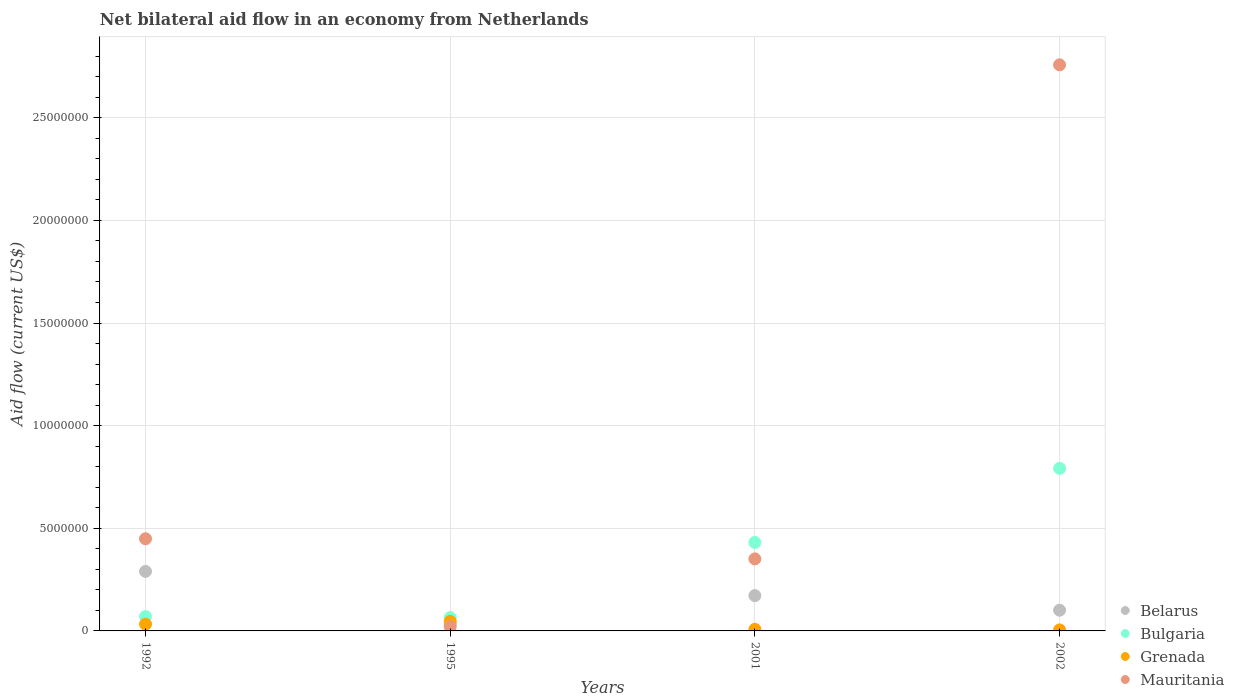Is the number of dotlines equal to the number of legend labels?
Your answer should be very brief. Yes. What is the net bilateral aid flow in Mauritania in 2001?
Your answer should be compact. 3.51e+06. Across all years, what is the maximum net bilateral aid flow in Mauritania?
Ensure brevity in your answer.  2.76e+07. In which year was the net bilateral aid flow in Mauritania maximum?
Provide a succinct answer. 2002. In which year was the net bilateral aid flow in Grenada minimum?
Offer a terse response. 2002. What is the total net bilateral aid flow in Mauritania in the graph?
Offer a very short reply. 3.58e+07. What is the difference between the net bilateral aid flow in Belarus in 1992 and that in 2002?
Your answer should be compact. 1.89e+06. What is the difference between the net bilateral aid flow in Grenada in 2002 and the net bilateral aid flow in Bulgaria in 1992?
Your answer should be compact. -6.50e+05. What is the average net bilateral aid flow in Mauritania per year?
Ensure brevity in your answer.  8.95e+06. In the year 2001, what is the difference between the net bilateral aid flow in Belarus and net bilateral aid flow in Bulgaria?
Your answer should be very brief. -2.59e+06. What is the ratio of the net bilateral aid flow in Bulgaria in 1992 to that in 2002?
Make the answer very short. 0.09. Is the net bilateral aid flow in Belarus in 1992 less than that in 1995?
Provide a short and direct response. No. Is the difference between the net bilateral aid flow in Belarus in 2001 and 2002 greater than the difference between the net bilateral aid flow in Bulgaria in 2001 and 2002?
Your response must be concise. Yes. What is the difference between the highest and the second highest net bilateral aid flow in Bulgaria?
Give a very brief answer. 3.61e+06. In how many years, is the net bilateral aid flow in Grenada greater than the average net bilateral aid flow in Grenada taken over all years?
Your answer should be compact. 2. Is it the case that in every year, the sum of the net bilateral aid flow in Bulgaria and net bilateral aid flow in Grenada  is greater than the sum of net bilateral aid flow in Belarus and net bilateral aid flow in Mauritania?
Your response must be concise. No. Is the net bilateral aid flow in Mauritania strictly less than the net bilateral aid flow in Bulgaria over the years?
Give a very brief answer. No. How many years are there in the graph?
Offer a terse response. 4. Are the values on the major ticks of Y-axis written in scientific E-notation?
Your answer should be very brief. No. Does the graph contain any zero values?
Offer a terse response. No. Does the graph contain grids?
Give a very brief answer. Yes. How many legend labels are there?
Your response must be concise. 4. How are the legend labels stacked?
Provide a succinct answer. Vertical. What is the title of the graph?
Provide a succinct answer. Net bilateral aid flow in an economy from Netherlands. Does "Cambodia" appear as one of the legend labels in the graph?
Your answer should be very brief. No. What is the label or title of the Y-axis?
Offer a very short reply. Aid flow (current US$). What is the Aid flow (current US$) in Belarus in 1992?
Ensure brevity in your answer.  2.90e+06. What is the Aid flow (current US$) in Grenada in 1992?
Your answer should be compact. 3.30e+05. What is the Aid flow (current US$) in Mauritania in 1992?
Provide a short and direct response. 4.49e+06. What is the Aid flow (current US$) in Belarus in 1995?
Make the answer very short. 3.40e+05. What is the Aid flow (current US$) of Bulgaria in 1995?
Ensure brevity in your answer.  6.50e+05. What is the Aid flow (current US$) of Grenada in 1995?
Provide a succinct answer. 4.70e+05. What is the Aid flow (current US$) of Mauritania in 1995?
Provide a short and direct response. 2.10e+05. What is the Aid flow (current US$) of Belarus in 2001?
Provide a succinct answer. 1.72e+06. What is the Aid flow (current US$) of Bulgaria in 2001?
Provide a succinct answer. 4.31e+06. What is the Aid flow (current US$) of Grenada in 2001?
Provide a succinct answer. 8.00e+04. What is the Aid flow (current US$) of Mauritania in 2001?
Make the answer very short. 3.51e+06. What is the Aid flow (current US$) in Belarus in 2002?
Your answer should be compact. 1.01e+06. What is the Aid flow (current US$) in Bulgaria in 2002?
Make the answer very short. 7.92e+06. What is the Aid flow (current US$) of Mauritania in 2002?
Offer a terse response. 2.76e+07. Across all years, what is the maximum Aid flow (current US$) in Belarus?
Provide a short and direct response. 2.90e+06. Across all years, what is the maximum Aid flow (current US$) in Bulgaria?
Offer a very short reply. 7.92e+06. Across all years, what is the maximum Aid flow (current US$) of Grenada?
Your answer should be compact. 4.70e+05. Across all years, what is the maximum Aid flow (current US$) in Mauritania?
Your answer should be very brief. 2.76e+07. Across all years, what is the minimum Aid flow (current US$) in Belarus?
Provide a succinct answer. 3.40e+05. Across all years, what is the minimum Aid flow (current US$) of Bulgaria?
Make the answer very short. 6.50e+05. Across all years, what is the minimum Aid flow (current US$) in Grenada?
Provide a short and direct response. 5.00e+04. Across all years, what is the minimum Aid flow (current US$) in Mauritania?
Give a very brief answer. 2.10e+05. What is the total Aid flow (current US$) of Belarus in the graph?
Make the answer very short. 5.97e+06. What is the total Aid flow (current US$) in Bulgaria in the graph?
Give a very brief answer. 1.36e+07. What is the total Aid flow (current US$) in Grenada in the graph?
Your answer should be very brief. 9.30e+05. What is the total Aid flow (current US$) in Mauritania in the graph?
Make the answer very short. 3.58e+07. What is the difference between the Aid flow (current US$) in Belarus in 1992 and that in 1995?
Your answer should be compact. 2.56e+06. What is the difference between the Aid flow (current US$) of Mauritania in 1992 and that in 1995?
Offer a very short reply. 4.28e+06. What is the difference between the Aid flow (current US$) of Belarus in 1992 and that in 2001?
Provide a short and direct response. 1.18e+06. What is the difference between the Aid flow (current US$) in Bulgaria in 1992 and that in 2001?
Ensure brevity in your answer.  -3.61e+06. What is the difference between the Aid flow (current US$) in Grenada in 1992 and that in 2001?
Provide a succinct answer. 2.50e+05. What is the difference between the Aid flow (current US$) of Mauritania in 1992 and that in 2001?
Provide a short and direct response. 9.80e+05. What is the difference between the Aid flow (current US$) of Belarus in 1992 and that in 2002?
Your response must be concise. 1.89e+06. What is the difference between the Aid flow (current US$) in Bulgaria in 1992 and that in 2002?
Make the answer very short. -7.22e+06. What is the difference between the Aid flow (current US$) of Mauritania in 1992 and that in 2002?
Provide a succinct answer. -2.31e+07. What is the difference between the Aid flow (current US$) in Belarus in 1995 and that in 2001?
Give a very brief answer. -1.38e+06. What is the difference between the Aid flow (current US$) in Bulgaria in 1995 and that in 2001?
Keep it short and to the point. -3.66e+06. What is the difference between the Aid flow (current US$) of Mauritania in 1995 and that in 2001?
Your answer should be compact. -3.30e+06. What is the difference between the Aid flow (current US$) of Belarus in 1995 and that in 2002?
Offer a very short reply. -6.70e+05. What is the difference between the Aid flow (current US$) in Bulgaria in 1995 and that in 2002?
Ensure brevity in your answer.  -7.27e+06. What is the difference between the Aid flow (current US$) in Grenada in 1995 and that in 2002?
Your response must be concise. 4.20e+05. What is the difference between the Aid flow (current US$) of Mauritania in 1995 and that in 2002?
Offer a terse response. -2.74e+07. What is the difference between the Aid flow (current US$) in Belarus in 2001 and that in 2002?
Make the answer very short. 7.10e+05. What is the difference between the Aid flow (current US$) of Bulgaria in 2001 and that in 2002?
Give a very brief answer. -3.61e+06. What is the difference between the Aid flow (current US$) in Mauritania in 2001 and that in 2002?
Your response must be concise. -2.41e+07. What is the difference between the Aid flow (current US$) of Belarus in 1992 and the Aid flow (current US$) of Bulgaria in 1995?
Offer a terse response. 2.25e+06. What is the difference between the Aid flow (current US$) of Belarus in 1992 and the Aid flow (current US$) of Grenada in 1995?
Make the answer very short. 2.43e+06. What is the difference between the Aid flow (current US$) of Belarus in 1992 and the Aid flow (current US$) of Mauritania in 1995?
Make the answer very short. 2.69e+06. What is the difference between the Aid flow (current US$) of Bulgaria in 1992 and the Aid flow (current US$) of Grenada in 1995?
Make the answer very short. 2.30e+05. What is the difference between the Aid flow (current US$) of Grenada in 1992 and the Aid flow (current US$) of Mauritania in 1995?
Keep it short and to the point. 1.20e+05. What is the difference between the Aid flow (current US$) of Belarus in 1992 and the Aid flow (current US$) of Bulgaria in 2001?
Keep it short and to the point. -1.41e+06. What is the difference between the Aid flow (current US$) in Belarus in 1992 and the Aid flow (current US$) in Grenada in 2001?
Your answer should be compact. 2.82e+06. What is the difference between the Aid flow (current US$) of Belarus in 1992 and the Aid flow (current US$) of Mauritania in 2001?
Your response must be concise. -6.10e+05. What is the difference between the Aid flow (current US$) in Bulgaria in 1992 and the Aid flow (current US$) in Grenada in 2001?
Keep it short and to the point. 6.20e+05. What is the difference between the Aid flow (current US$) in Bulgaria in 1992 and the Aid flow (current US$) in Mauritania in 2001?
Keep it short and to the point. -2.81e+06. What is the difference between the Aid flow (current US$) in Grenada in 1992 and the Aid flow (current US$) in Mauritania in 2001?
Provide a succinct answer. -3.18e+06. What is the difference between the Aid flow (current US$) in Belarus in 1992 and the Aid flow (current US$) in Bulgaria in 2002?
Make the answer very short. -5.02e+06. What is the difference between the Aid flow (current US$) of Belarus in 1992 and the Aid flow (current US$) of Grenada in 2002?
Provide a succinct answer. 2.85e+06. What is the difference between the Aid flow (current US$) in Belarus in 1992 and the Aid flow (current US$) in Mauritania in 2002?
Provide a short and direct response. -2.47e+07. What is the difference between the Aid flow (current US$) of Bulgaria in 1992 and the Aid flow (current US$) of Grenada in 2002?
Keep it short and to the point. 6.50e+05. What is the difference between the Aid flow (current US$) in Bulgaria in 1992 and the Aid flow (current US$) in Mauritania in 2002?
Offer a terse response. -2.69e+07. What is the difference between the Aid flow (current US$) of Grenada in 1992 and the Aid flow (current US$) of Mauritania in 2002?
Keep it short and to the point. -2.72e+07. What is the difference between the Aid flow (current US$) in Belarus in 1995 and the Aid flow (current US$) in Bulgaria in 2001?
Offer a very short reply. -3.97e+06. What is the difference between the Aid flow (current US$) of Belarus in 1995 and the Aid flow (current US$) of Grenada in 2001?
Keep it short and to the point. 2.60e+05. What is the difference between the Aid flow (current US$) of Belarus in 1995 and the Aid flow (current US$) of Mauritania in 2001?
Your answer should be compact. -3.17e+06. What is the difference between the Aid flow (current US$) of Bulgaria in 1995 and the Aid flow (current US$) of Grenada in 2001?
Give a very brief answer. 5.70e+05. What is the difference between the Aid flow (current US$) in Bulgaria in 1995 and the Aid flow (current US$) in Mauritania in 2001?
Your response must be concise. -2.86e+06. What is the difference between the Aid flow (current US$) in Grenada in 1995 and the Aid flow (current US$) in Mauritania in 2001?
Ensure brevity in your answer.  -3.04e+06. What is the difference between the Aid flow (current US$) of Belarus in 1995 and the Aid flow (current US$) of Bulgaria in 2002?
Offer a very short reply. -7.58e+06. What is the difference between the Aid flow (current US$) in Belarus in 1995 and the Aid flow (current US$) in Grenada in 2002?
Keep it short and to the point. 2.90e+05. What is the difference between the Aid flow (current US$) of Belarus in 1995 and the Aid flow (current US$) of Mauritania in 2002?
Provide a succinct answer. -2.72e+07. What is the difference between the Aid flow (current US$) of Bulgaria in 1995 and the Aid flow (current US$) of Mauritania in 2002?
Your response must be concise. -2.69e+07. What is the difference between the Aid flow (current US$) in Grenada in 1995 and the Aid flow (current US$) in Mauritania in 2002?
Your response must be concise. -2.71e+07. What is the difference between the Aid flow (current US$) of Belarus in 2001 and the Aid flow (current US$) of Bulgaria in 2002?
Your answer should be compact. -6.20e+06. What is the difference between the Aid flow (current US$) of Belarus in 2001 and the Aid flow (current US$) of Grenada in 2002?
Make the answer very short. 1.67e+06. What is the difference between the Aid flow (current US$) in Belarus in 2001 and the Aid flow (current US$) in Mauritania in 2002?
Give a very brief answer. -2.59e+07. What is the difference between the Aid flow (current US$) in Bulgaria in 2001 and the Aid flow (current US$) in Grenada in 2002?
Provide a succinct answer. 4.26e+06. What is the difference between the Aid flow (current US$) in Bulgaria in 2001 and the Aid flow (current US$) in Mauritania in 2002?
Make the answer very short. -2.33e+07. What is the difference between the Aid flow (current US$) in Grenada in 2001 and the Aid flow (current US$) in Mauritania in 2002?
Give a very brief answer. -2.75e+07. What is the average Aid flow (current US$) in Belarus per year?
Your response must be concise. 1.49e+06. What is the average Aid flow (current US$) of Bulgaria per year?
Make the answer very short. 3.40e+06. What is the average Aid flow (current US$) in Grenada per year?
Provide a succinct answer. 2.32e+05. What is the average Aid flow (current US$) of Mauritania per year?
Your answer should be very brief. 8.95e+06. In the year 1992, what is the difference between the Aid flow (current US$) of Belarus and Aid flow (current US$) of Bulgaria?
Offer a very short reply. 2.20e+06. In the year 1992, what is the difference between the Aid flow (current US$) of Belarus and Aid flow (current US$) of Grenada?
Offer a terse response. 2.57e+06. In the year 1992, what is the difference between the Aid flow (current US$) of Belarus and Aid flow (current US$) of Mauritania?
Your answer should be compact. -1.59e+06. In the year 1992, what is the difference between the Aid flow (current US$) of Bulgaria and Aid flow (current US$) of Grenada?
Your answer should be compact. 3.70e+05. In the year 1992, what is the difference between the Aid flow (current US$) of Bulgaria and Aid flow (current US$) of Mauritania?
Provide a succinct answer. -3.79e+06. In the year 1992, what is the difference between the Aid flow (current US$) in Grenada and Aid flow (current US$) in Mauritania?
Offer a terse response. -4.16e+06. In the year 1995, what is the difference between the Aid flow (current US$) in Belarus and Aid flow (current US$) in Bulgaria?
Give a very brief answer. -3.10e+05. In the year 1995, what is the difference between the Aid flow (current US$) in Bulgaria and Aid flow (current US$) in Grenada?
Give a very brief answer. 1.80e+05. In the year 1995, what is the difference between the Aid flow (current US$) of Bulgaria and Aid flow (current US$) of Mauritania?
Provide a short and direct response. 4.40e+05. In the year 1995, what is the difference between the Aid flow (current US$) in Grenada and Aid flow (current US$) in Mauritania?
Give a very brief answer. 2.60e+05. In the year 2001, what is the difference between the Aid flow (current US$) of Belarus and Aid flow (current US$) of Bulgaria?
Keep it short and to the point. -2.59e+06. In the year 2001, what is the difference between the Aid flow (current US$) of Belarus and Aid flow (current US$) of Grenada?
Your answer should be compact. 1.64e+06. In the year 2001, what is the difference between the Aid flow (current US$) in Belarus and Aid flow (current US$) in Mauritania?
Your answer should be very brief. -1.79e+06. In the year 2001, what is the difference between the Aid flow (current US$) of Bulgaria and Aid flow (current US$) of Grenada?
Your response must be concise. 4.23e+06. In the year 2001, what is the difference between the Aid flow (current US$) in Bulgaria and Aid flow (current US$) in Mauritania?
Offer a terse response. 8.00e+05. In the year 2001, what is the difference between the Aid flow (current US$) of Grenada and Aid flow (current US$) of Mauritania?
Keep it short and to the point. -3.43e+06. In the year 2002, what is the difference between the Aid flow (current US$) of Belarus and Aid flow (current US$) of Bulgaria?
Your response must be concise. -6.91e+06. In the year 2002, what is the difference between the Aid flow (current US$) in Belarus and Aid flow (current US$) in Grenada?
Your answer should be compact. 9.60e+05. In the year 2002, what is the difference between the Aid flow (current US$) of Belarus and Aid flow (current US$) of Mauritania?
Give a very brief answer. -2.66e+07. In the year 2002, what is the difference between the Aid flow (current US$) in Bulgaria and Aid flow (current US$) in Grenada?
Your response must be concise. 7.87e+06. In the year 2002, what is the difference between the Aid flow (current US$) in Bulgaria and Aid flow (current US$) in Mauritania?
Ensure brevity in your answer.  -1.97e+07. In the year 2002, what is the difference between the Aid flow (current US$) in Grenada and Aid flow (current US$) in Mauritania?
Provide a short and direct response. -2.75e+07. What is the ratio of the Aid flow (current US$) in Belarus in 1992 to that in 1995?
Make the answer very short. 8.53. What is the ratio of the Aid flow (current US$) in Grenada in 1992 to that in 1995?
Provide a succinct answer. 0.7. What is the ratio of the Aid flow (current US$) in Mauritania in 1992 to that in 1995?
Your answer should be compact. 21.38. What is the ratio of the Aid flow (current US$) of Belarus in 1992 to that in 2001?
Give a very brief answer. 1.69. What is the ratio of the Aid flow (current US$) in Bulgaria in 1992 to that in 2001?
Keep it short and to the point. 0.16. What is the ratio of the Aid flow (current US$) of Grenada in 1992 to that in 2001?
Ensure brevity in your answer.  4.12. What is the ratio of the Aid flow (current US$) in Mauritania in 1992 to that in 2001?
Your response must be concise. 1.28. What is the ratio of the Aid flow (current US$) of Belarus in 1992 to that in 2002?
Provide a short and direct response. 2.87. What is the ratio of the Aid flow (current US$) in Bulgaria in 1992 to that in 2002?
Your answer should be compact. 0.09. What is the ratio of the Aid flow (current US$) in Mauritania in 1992 to that in 2002?
Make the answer very short. 0.16. What is the ratio of the Aid flow (current US$) in Belarus in 1995 to that in 2001?
Ensure brevity in your answer.  0.2. What is the ratio of the Aid flow (current US$) of Bulgaria in 1995 to that in 2001?
Give a very brief answer. 0.15. What is the ratio of the Aid flow (current US$) of Grenada in 1995 to that in 2001?
Your answer should be very brief. 5.88. What is the ratio of the Aid flow (current US$) in Mauritania in 1995 to that in 2001?
Keep it short and to the point. 0.06. What is the ratio of the Aid flow (current US$) of Belarus in 1995 to that in 2002?
Offer a terse response. 0.34. What is the ratio of the Aid flow (current US$) of Bulgaria in 1995 to that in 2002?
Your answer should be compact. 0.08. What is the ratio of the Aid flow (current US$) in Mauritania in 1995 to that in 2002?
Your answer should be compact. 0.01. What is the ratio of the Aid flow (current US$) of Belarus in 2001 to that in 2002?
Provide a succinct answer. 1.7. What is the ratio of the Aid flow (current US$) in Bulgaria in 2001 to that in 2002?
Offer a very short reply. 0.54. What is the ratio of the Aid flow (current US$) of Mauritania in 2001 to that in 2002?
Keep it short and to the point. 0.13. What is the difference between the highest and the second highest Aid flow (current US$) in Belarus?
Offer a terse response. 1.18e+06. What is the difference between the highest and the second highest Aid flow (current US$) of Bulgaria?
Your response must be concise. 3.61e+06. What is the difference between the highest and the second highest Aid flow (current US$) of Grenada?
Your answer should be compact. 1.40e+05. What is the difference between the highest and the second highest Aid flow (current US$) of Mauritania?
Your response must be concise. 2.31e+07. What is the difference between the highest and the lowest Aid flow (current US$) of Belarus?
Your response must be concise. 2.56e+06. What is the difference between the highest and the lowest Aid flow (current US$) of Bulgaria?
Offer a terse response. 7.27e+06. What is the difference between the highest and the lowest Aid flow (current US$) in Grenada?
Ensure brevity in your answer.  4.20e+05. What is the difference between the highest and the lowest Aid flow (current US$) in Mauritania?
Give a very brief answer. 2.74e+07. 